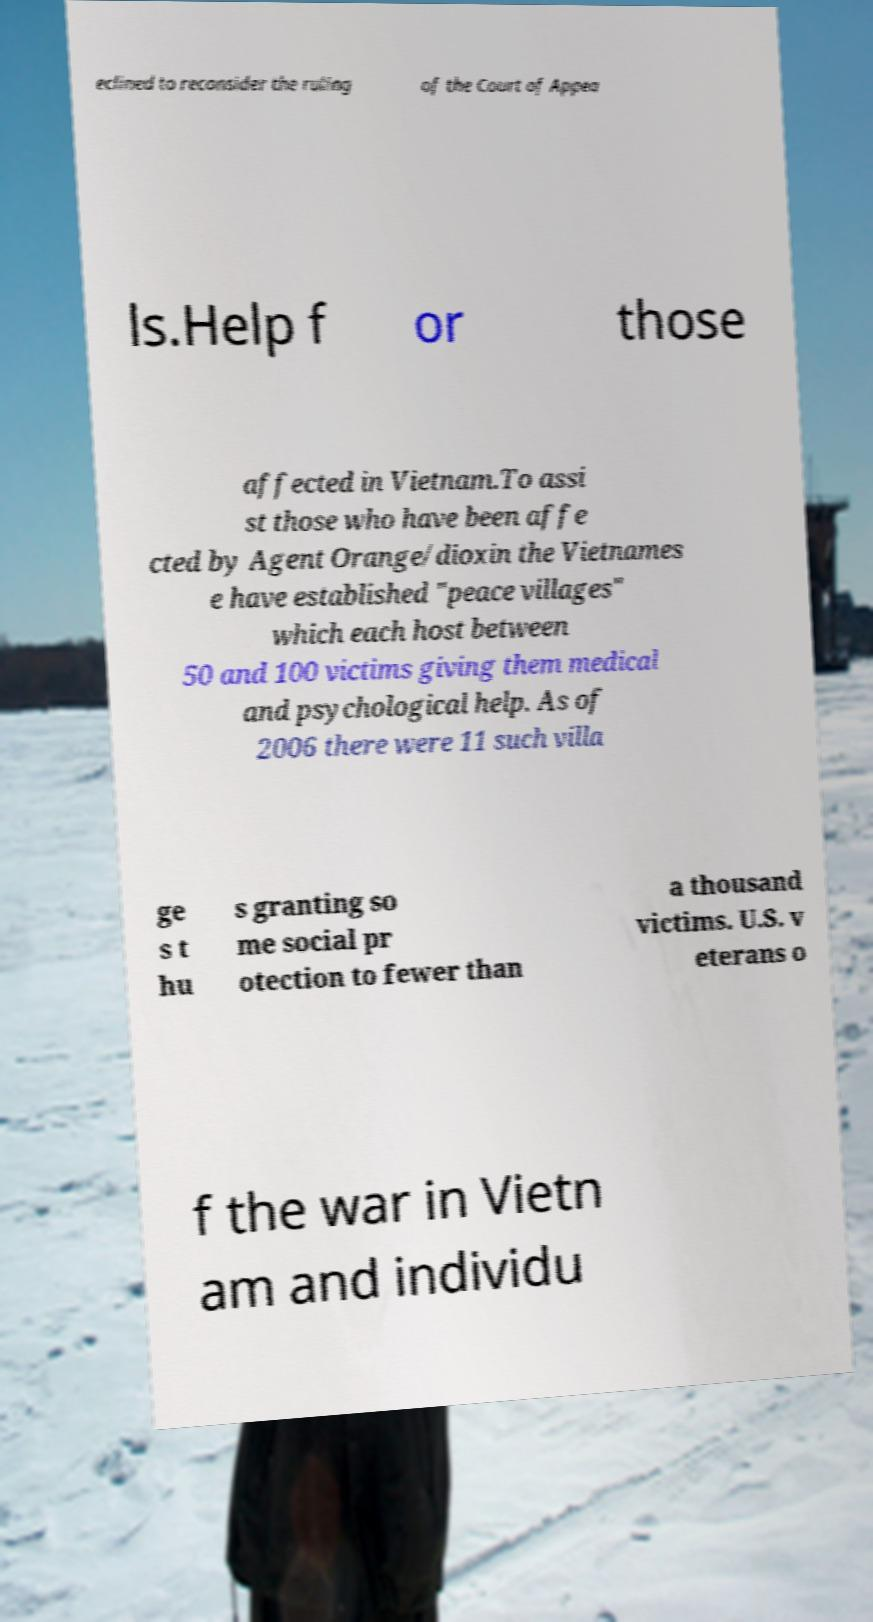Can you accurately transcribe the text from the provided image for me? eclined to reconsider the ruling of the Court of Appea ls.Help f or those affected in Vietnam.To assi st those who have been affe cted by Agent Orange/dioxin the Vietnames e have established "peace villages" which each host between 50 and 100 victims giving them medical and psychological help. As of 2006 there were 11 such villa ge s t hu s granting so me social pr otection to fewer than a thousand victims. U.S. v eterans o f the war in Vietn am and individu 